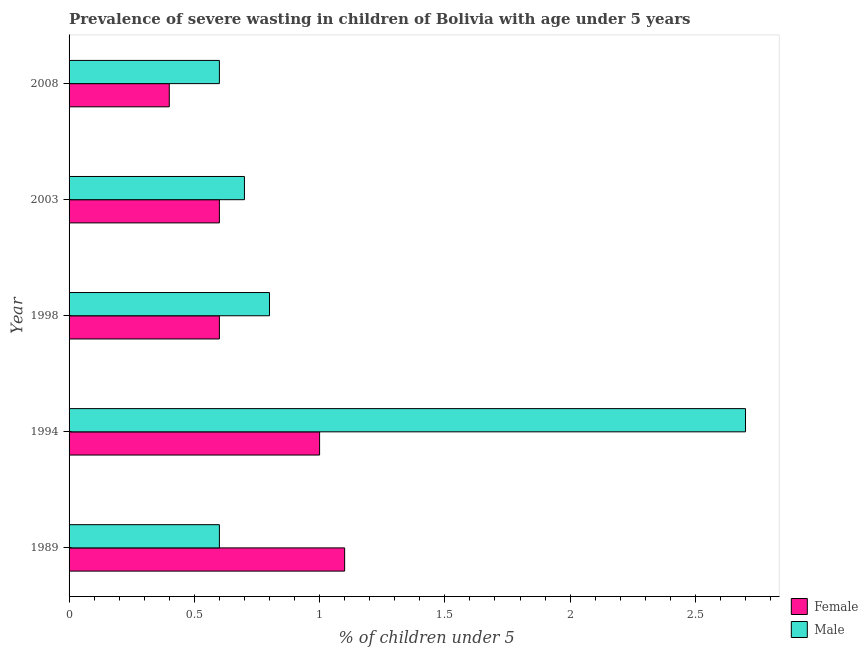How many different coloured bars are there?
Provide a short and direct response. 2. Are the number of bars per tick equal to the number of legend labels?
Your response must be concise. Yes. How many bars are there on the 3rd tick from the top?
Keep it short and to the point. 2. What is the percentage of undernourished female children in 1998?
Ensure brevity in your answer.  0.6. Across all years, what is the maximum percentage of undernourished male children?
Keep it short and to the point. 2.7. Across all years, what is the minimum percentage of undernourished female children?
Ensure brevity in your answer.  0.4. In which year was the percentage of undernourished female children maximum?
Keep it short and to the point. 1989. What is the total percentage of undernourished male children in the graph?
Provide a succinct answer. 5.4. What is the difference between the percentage of undernourished male children in 1989 and that in 2003?
Make the answer very short. -0.1. What is the difference between the percentage of undernourished male children in 1989 and the percentage of undernourished female children in 1994?
Offer a very short reply. -0.4. What is the average percentage of undernourished male children per year?
Your response must be concise. 1.08. In the year 2003, what is the difference between the percentage of undernourished male children and percentage of undernourished female children?
Ensure brevity in your answer.  0.1. In how many years, is the percentage of undernourished female children greater than 2 %?
Offer a very short reply. 0. Is the percentage of undernourished female children in 2003 less than that in 2008?
Offer a terse response. No. Is the difference between the percentage of undernourished male children in 1989 and 1994 greater than the difference between the percentage of undernourished female children in 1989 and 1994?
Ensure brevity in your answer.  No. What is the difference between the highest and the second highest percentage of undernourished female children?
Keep it short and to the point. 0.1. What does the 1st bar from the bottom in 2003 represents?
Your response must be concise. Female. How many bars are there?
Provide a short and direct response. 10. Are all the bars in the graph horizontal?
Give a very brief answer. Yes. Does the graph contain any zero values?
Offer a very short reply. No. Does the graph contain grids?
Offer a very short reply. No. Where does the legend appear in the graph?
Offer a terse response. Bottom right. What is the title of the graph?
Make the answer very short. Prevalence of severe wasting in children of Bolivia with age under 5 years. Does "Female population" appear as one of the legend labels in the graph?
Keep it short and to the point. No. What is the label or title of the X-axis?
Offer a very short reply.  % of children under 5. What is the label or title of the Y-axis?
Ensure brevity in your answer.  Year. What is the  % of children under 5 of Female in 1989?
Your answer should be compact. 1.1. What is the  % of children under 5 in Male in 1989?
Keep it short and to the point. 0.6. What is the  % of children under 5 of Male in 1994?
Give a very brief answer. 2.7. What is the  % of children under 5 of Female in 1998?
Offer a very short reply. 0.6. What is the  % of children under 5 in Male in 1998?
Offer a terse response. 0.8. What is the  % of children under 5 in Female in 2003?
Make the answer very short. 0.6. What is the  % of children under 5 of Male in 2003?
Provide a short and direct response. 0.7. What is the  % of children under 5 in Female in 2008?
Provide a short and direct response. 0.4. What is the  % of children under 5 in Male in 2008?
Keep it short and to the point. 0.6. Across all years, what is the maximum  % of children under 5 in Female?
Keep it short and to the point. 1.1. Across all years, what is the maximum  % of children under 5 of Male?
Offer a terse response. 2.7. Across all years, what is the minimum  % of children under 5 of Female?
Offer a very short reply. 0.4. Across all years, what is the minimum  % of children under 5 in Male?
Offer a terse response. 0.6. What is the difference between the  % of children under 5 in Male in 1989 and that in 2003?
Give a very brief answer. -0.1. What is the difference between the  % of children under 5 in Female in 1989 and that in 2008?
Provide a succinct answer. 0.7. What is the difference between the  % of children under 5 of Male in 1989 and that in 2008?
Give a very brief answer. 0. What is the difference between the  % of children under 5 of Female in 1994 and that in 1998?
Provide a short and direct response. 0.4. What is the difference between the  % of children under 5 of Male in 1994 and that in 2003?
Provide a short and direct response. 2. What is the difference between the  % of children under 5 in Female in 1994 and that in 2008?
Your response must be concise. 0.6. What is the difference between the  % of children under 5 in Female in 1998 and that in 2003?
Provide a short and direct response. 0. What is the difference between the  % of children under 5 of Male in 1998 and that in 2003?
Your answer should be compact. 0.1. What is the difference between the  % of children under 5 in Female in 1998 and that in 2008?
Offer a very short reply. 0.2. What is the difference between the  % of children under 5 in Male in 1998 and that in 2008?
Offer a very short reply. 0.2. What is the difference between the  % of children under 5 in Female in 2003 and that in 2008?
Ensure brevity in your answer.  0.2. What is the difference between the  % of children under 5 of Male in 2003 and that in 2008?
Offer a very short reply. 0.1. What is the difference between the  % of children under 5 in Female in 1989 and the  % of children under 5 in Male in 1994?
Your answer should be compact. -1.6. What is the difference between the  % of children under 5 in Female in 1989 and the  % of children under 5 in Male in 2003?
Ensure brevity in your answer.  0.4. What is the difference between the  % of children under 5 of Female in 1994 and the  % of children under 5 of Male in 1998?
Provide a short and direct response. 0.2. What is the difference between the  % of children under 5 in Female in 1994 and the  % of children under 5 in Male in 2003?
Keep it short and to the point. 0.3. What is the difference between the  % of children under 5 in Female in 1994 and the  % of children under 5 in Male in 2008?
Make the answer very short. 0.4. What is the difference between the  % of children under 5 in Female in 1998 and the  % of children under 5 in Male in 2003?
Provide a succinct answer. -0.1. What is the difference between the  % of children under 5 of Female in 1998 and the  % of children under 5 of Male in 2008?
Provide a succinct answer. 0. What is the average  % of children under 5 in Female per year?
Give a very brief answer. 0.74. What is the average  % of children under 5 in Male per year?
Offer a very short reply. 1.08. In the year 1989, what is the difference between the  % of children under 5 of Female and  % of children under 5 of Male?
Keep it short and to the point. 0.5. In the year 2003, what is the difference between the  % of children under 5 of Female and  % of children under 5 of Male?
Provide a succinct answer. -0.1. In the year 2008, what is the difference between the  % of children under 5 in Female and  % of children under 5 in Male?
Keep it short and to the point. -0.2. What is the ratio of the  % of children under 5 in Male in 1989 to that in 1994?
Ensure brevity in your answer.  0.22. What is the ratio of the  % of children under 5 of Female in 1989 to that in 1998?
Ensure brevity in your answer.  1.83. What is the ratio of the  % of children under 5 in Female in 1989 to that in 2003?
Your answer should be very brief. 1.83. What is the ratio of the  % of children under 5 of Female in 1989 to that in 2008?
Your answer should be very brief. 2.75. What is the ratio of the  % of children under 5 in Male in 1989 to that in 2008?
Offer a terse response. 1. What is the ratio of the  % of children under 5 of Male in 1994 to that in 1998?
Provide a succinct answer. 3.38. What is the ratio of the  % of children under 5 in Male in 1994 to that in 2003?
Your answer should be very brief. 3.86. What is the ratio of the  % of children under 5 in Female in 1994 to that in 2008?
Your answer should be compact. 2.5. What is the ratio of the  % of children under 5 in Male in 1994 to that in 2008?
Provide a succinct answer. 4.5. What is the ratio of the  % of children under 5 of Female in 1998 to that in 2003?
Keep it short and to the point. 1. What is the ratio of the  % of children under 5 in Male in 1998 to that in 2003?
Your answer should be compact. 1.14. What is the ratio of the  % of children under 5 of Female in 1998 to that in 2008?
Your response must be concise. 1.5. What is the ratio of the  % of children under 5 of Male in 1998 to that in 2008?
Provide a succinct answer. 1.33. What is the ratio of the  % of children under 5 in Female in 2003 to that in 2008?
Your answer should be compact. 1.5. What is the ratio of the  % of children under 5 in Male in 2003 to that in 2008?
Your answer should be very brief. 1.17. What is the difference between the highest and the second highest  % of children under 5 in Female?
Your answer should be very brief. 0.1. What is the difference between the highest and the second highest  % of children under 5 of Male?
Your answer should be compact. 1.9. What is the difference between the highest and the lowest  % of children under 5 in Female?
Your answer should be compact. 0.7. What is the difference between the highest and the lowest  % of children under 5 of Male?
Keep it short and to the point. 2.1. 